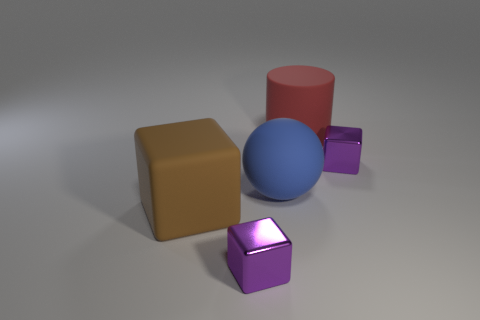Add 3 metallic objects. How many objects exist? 8 Subtract all cubes. How many objects are left? 2 Subtract 1 blue balls. How many objects are left? 4 Subtract all large brown things. Subtract all large blue cylinders. How many objects are left? 4 Add 3 big blocks. How many big blocks are left? 4 Add 1 metallic balls. How many metallic balls exist? 1 